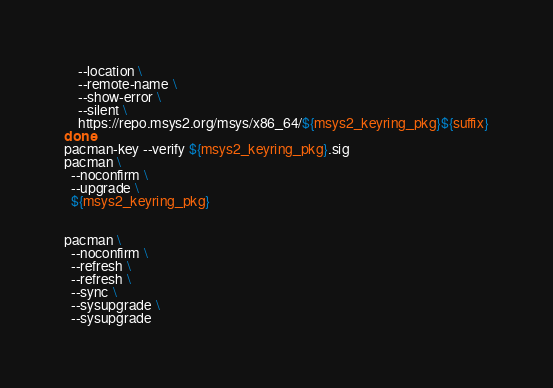Convert code to text. <code><loc_0><loc_0><loc_500><loc_500><_Bash_>    --location \
    --remote-name \
    --show-error \
    --silent \
    https://repo.msys2.org/msys/x86_64/${msys2_keyring_pkg}${suffix}
done
pacman-key --verify ${msys2_keyring_pkg}.sig
pacman \
  --noconfirm \
  --upgrade \
  ${msys2_keyring_pkg}


pacman \
  --noconfirm \
  --refresh \
  --refresh \
  --sync \
  --sysupgrade \
  --sysupgrade
</code> 